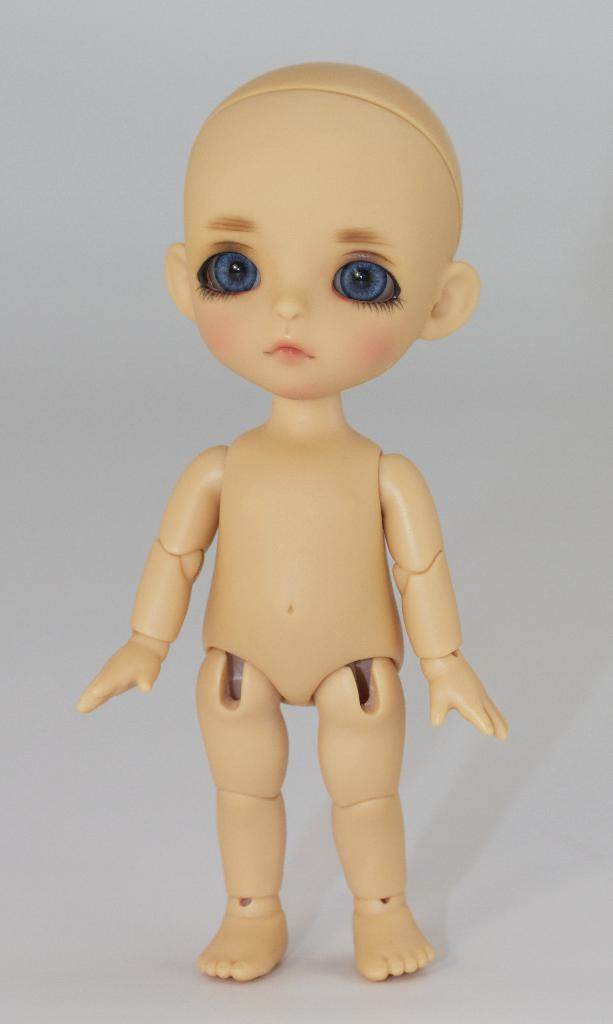What object can be seen in the image? There is a toy in the image. What color is the background of the image? The background of the image is white. What type of knowledge is being shared by the toy in the image? The toy in the image is not sharing any knowledge, as it is an inanimate object. 